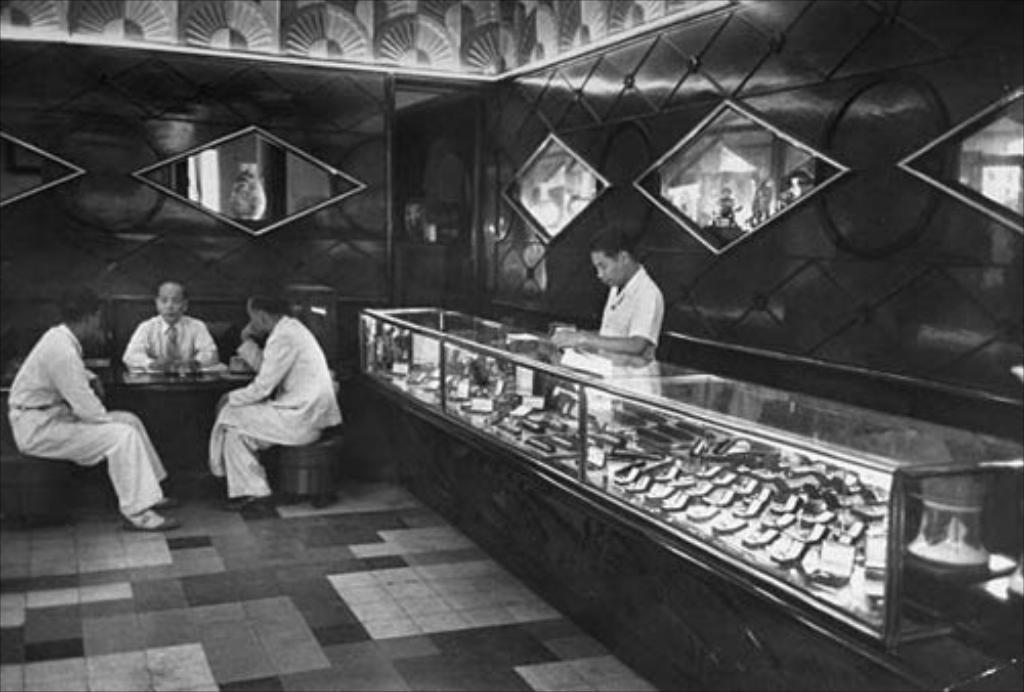What type of setting is shown in the image? The image depicts an inside view of a room. How many people are present in the room? There are four men in the image. What are the positions of the men in the room? Three of the men are sitting on chairs, and one man is standing. What is the color scheme of the image? The image is in black and white. What type of gold jewelry is the man wearing in the image? There is no gold jewelry visible on any of the men in the image, as it is in black and white. What type of joke is being told by the standing man in the image? There is no indication of a joke being told in the image, as there is no dialogue or facial expressions suggesting humor. 